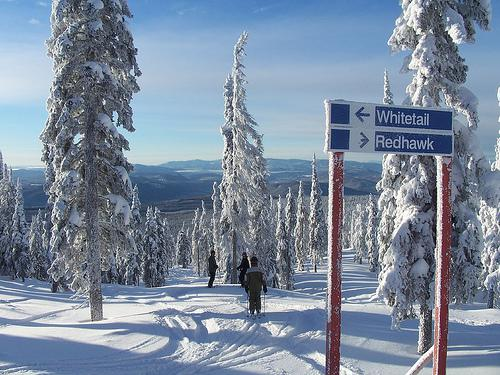Question: where was the picture taken from?
Choices:
A. Hillside.
B. Tundra.
C. Ski slope.
D. Canada.
Answer with the letter. Answer: C Question: how many people are there?
Choices:
A. 3.
B. 4.
C. 5.
D. 6.
Answer with the letter. Answer: A Question: what are the men doing?
Choices:
A. Skiing.
B. Snowboarding.
C. Sledding.
D. Running.
Answer with the letter. Answer: A Question: why are they standing?
Choices:
A. Watch.
B. Listen.
C. Talk.
D. Smell.
Answer with the letter. Answer: C Question: what is the color of the snow?
Choices:
A. Blue.
B. White.
C. Light blue.
D. Grey.
Answer with the letter. Answer: B Question: who is dancing?
Choices:
A. Everyone.
B. Half of the crowd.
C. Only the women.
D. No one.
Answer with the letter. Answer: D 